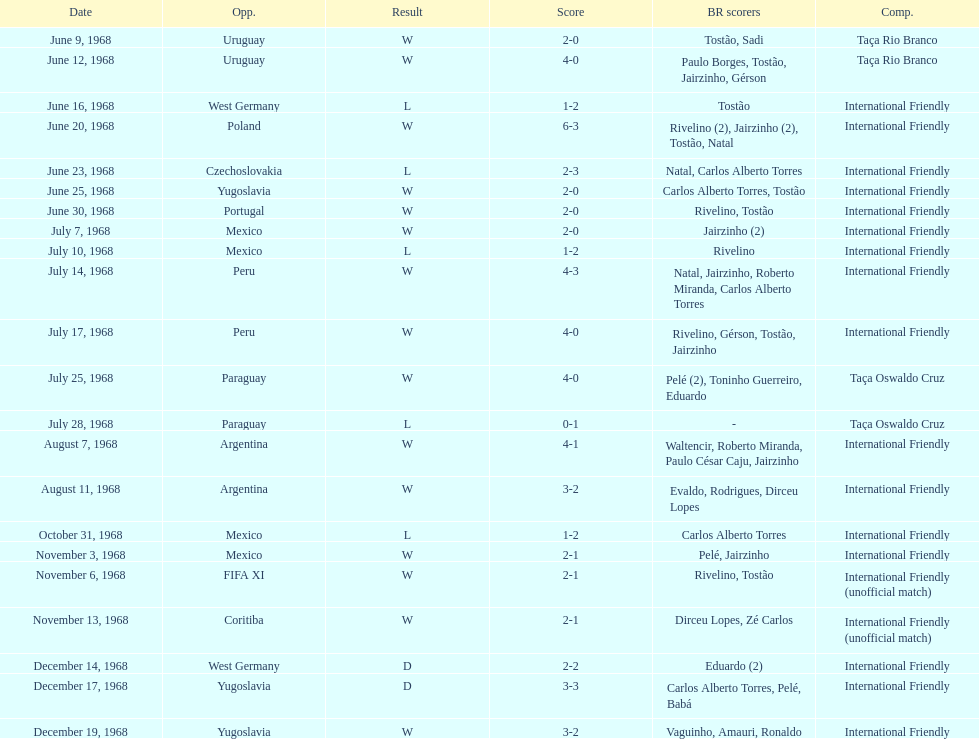How many countries have they participated in games? 11. 